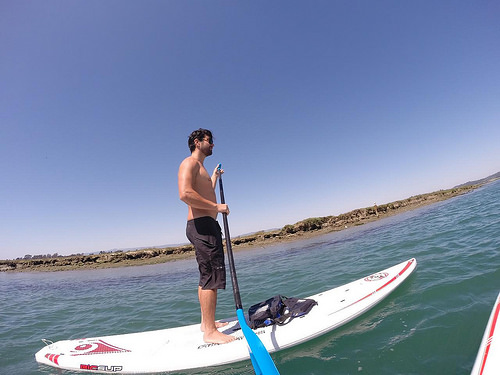<image>
Is the sky behind the land? Yes. From this viewpoint, the sky is positioned behind the land, with the land partially or fully occluding the sky. Is the man in the water? No. The man is not contained within the water. These objects have a different spatial relationship. 